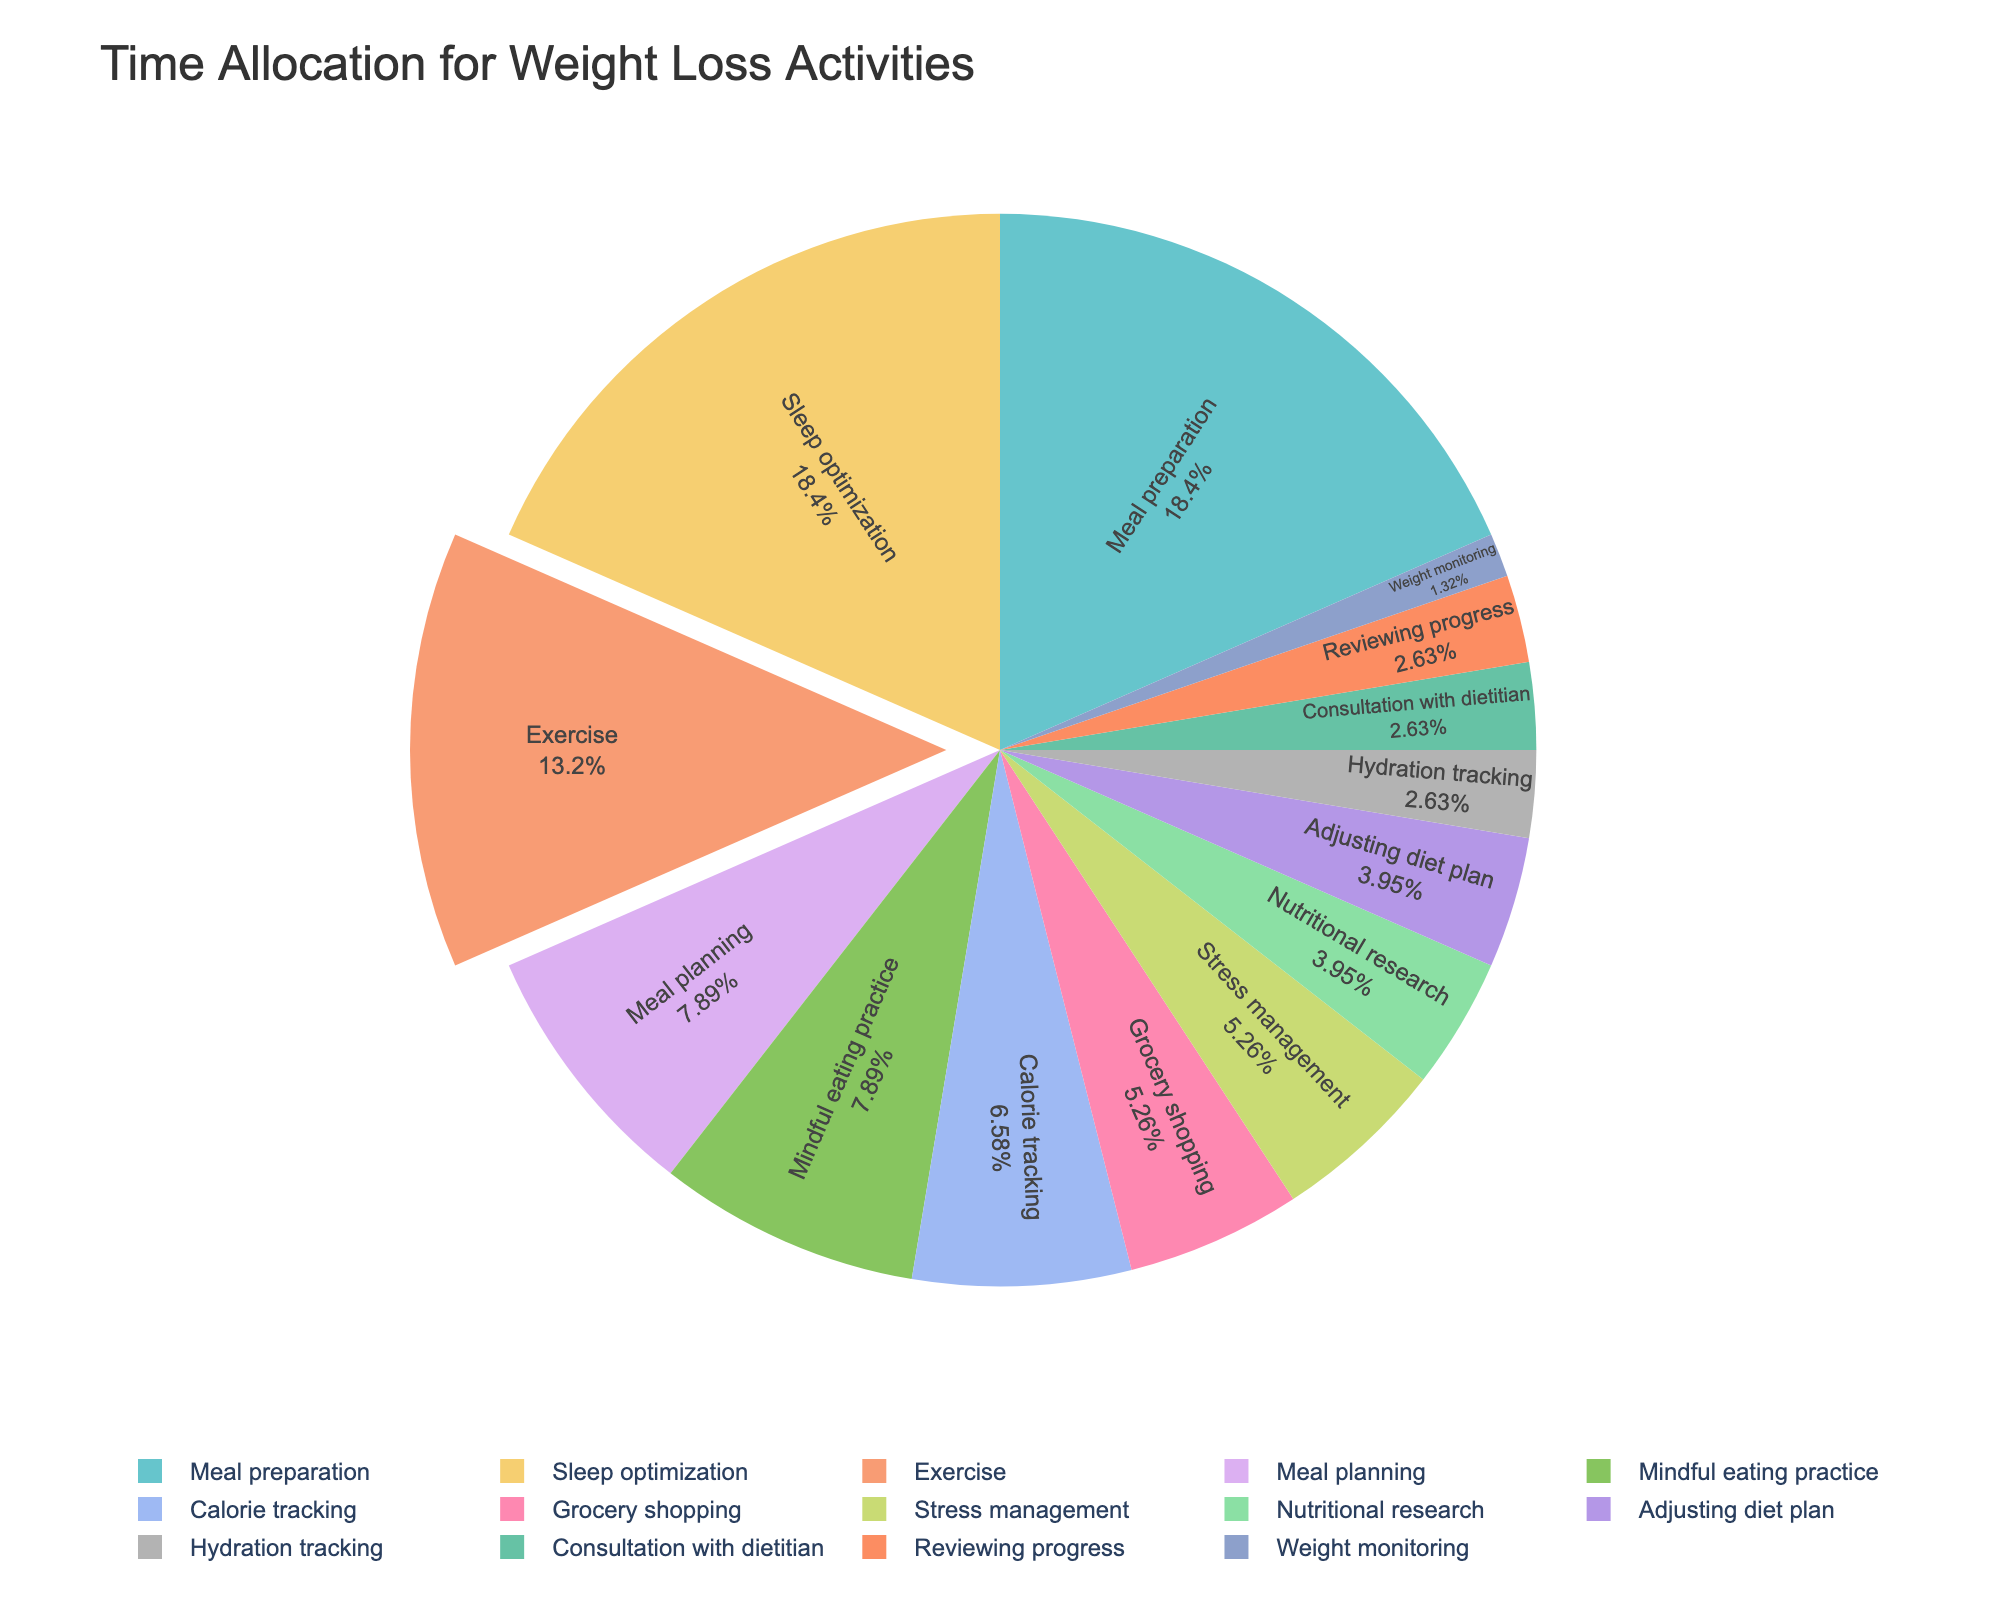What activity takes up the most hours in a week? The activity with the largest percentage or segment in the pie chart indicates it takes up the most hours. By visual inspection, it’s the segment labeled "Sleep optimization".
Answer: Sleep optimization Which activities take up the same amount of time? By inspecting the pie chart, look for segments of equal size and the same percentage label. Activities like "Consultation with dietitian," "Reviewing progress," and "Adjusting diet plan" each take up 1 hour, as indicated by their equal segment sizes.
Answer: Consultation with dietitian, Reviewing progress, Adjusting diet plan Which activities take up more than 5% of the total time allocation each week? By observing the pie chart, identify the segments labeled with percentages greater than 5%. The activities with larger segments are "Sleep optimization" (7 hours), "Meal preparation" (7 hours), "Exercise" (5 hours), and "Mindful eating practice" (3 hours).
Answer: Sleep optimization, Meal preparation, Exercise, Mindful eating practice How does the time spent on meal planning compare to the time spent on exercise? By comparing the individual segments of "Meal planning" and "Exercise" in the pie chart, "Exercise" (5 hours) has a larger segment than "Meal planning" (3 hours), showing that more time is allocated to exercise.
Answer: Exercise > Meal planning What is the total time spent on calorie tracking, hydration tracking, and weight monitoring? Add the hours spent on each activity: Calorie tracking (2.5) + Hydration tracking (1) + Weight monitoring (0.5).
Answer: 4 hours 